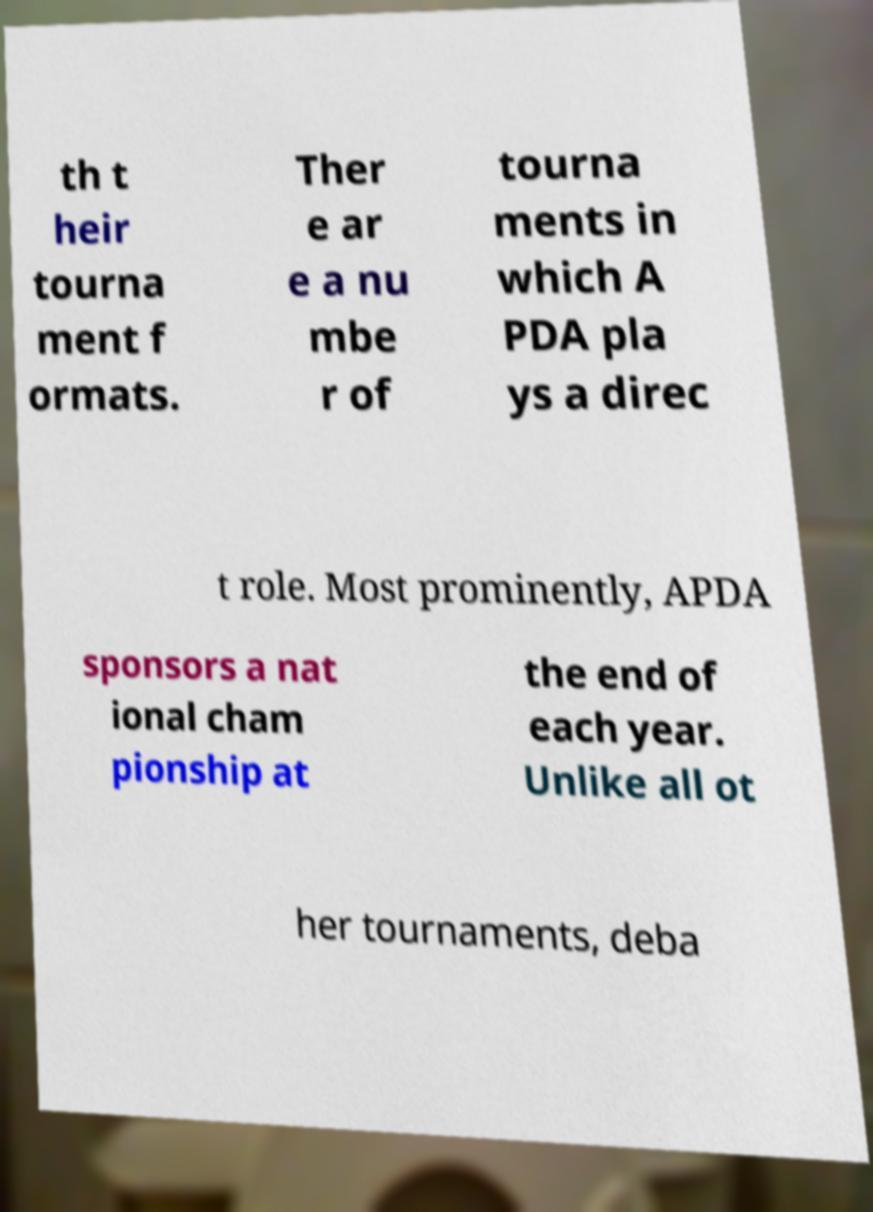Please identify and transcribe the text found in this image. th t heir tourna ment f ormats. Ther e ar e a nu mbe r of tourna ments in which A PDA pla ys a direc t role. Most prominently, APDA sponsors a nat ional cham pionship at the end of each year. Unlike all ot her tournaments, deba 